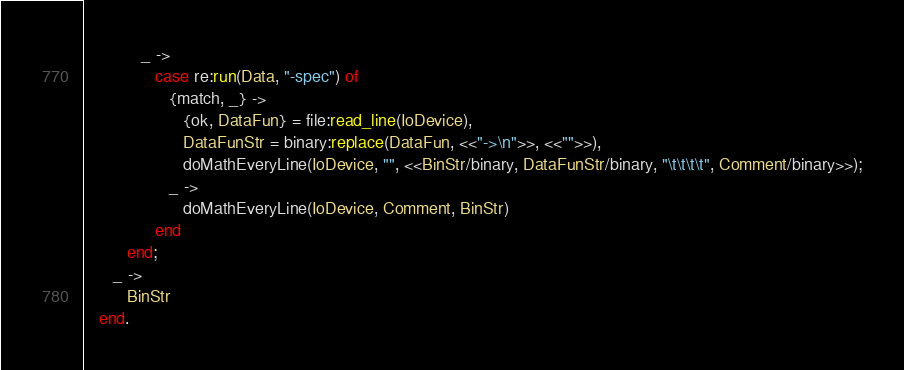<code> <loc_0><loc_0><loc_500><loc_500><_Erlang_>            _ ->
               case re:run(Data, "-spec") of
                  {match, _} ->
                     {ok, DataFun} = file:read_line(IoDevice),
                     DataFunStr = binary:replace(DataFun, <<"->\n">>, <<"">>),
                     doMathEveryLine(IoDevice, "", <<BinStr/binary, DataFunStr/binary, "\t\t\t\t", Comment/binary>>);
                  _ ->
                     doMathEveryLine(IoDevice, Comment, BinStr)
               end
         end;
      _ ->
         BinStr
   end.
</code> 